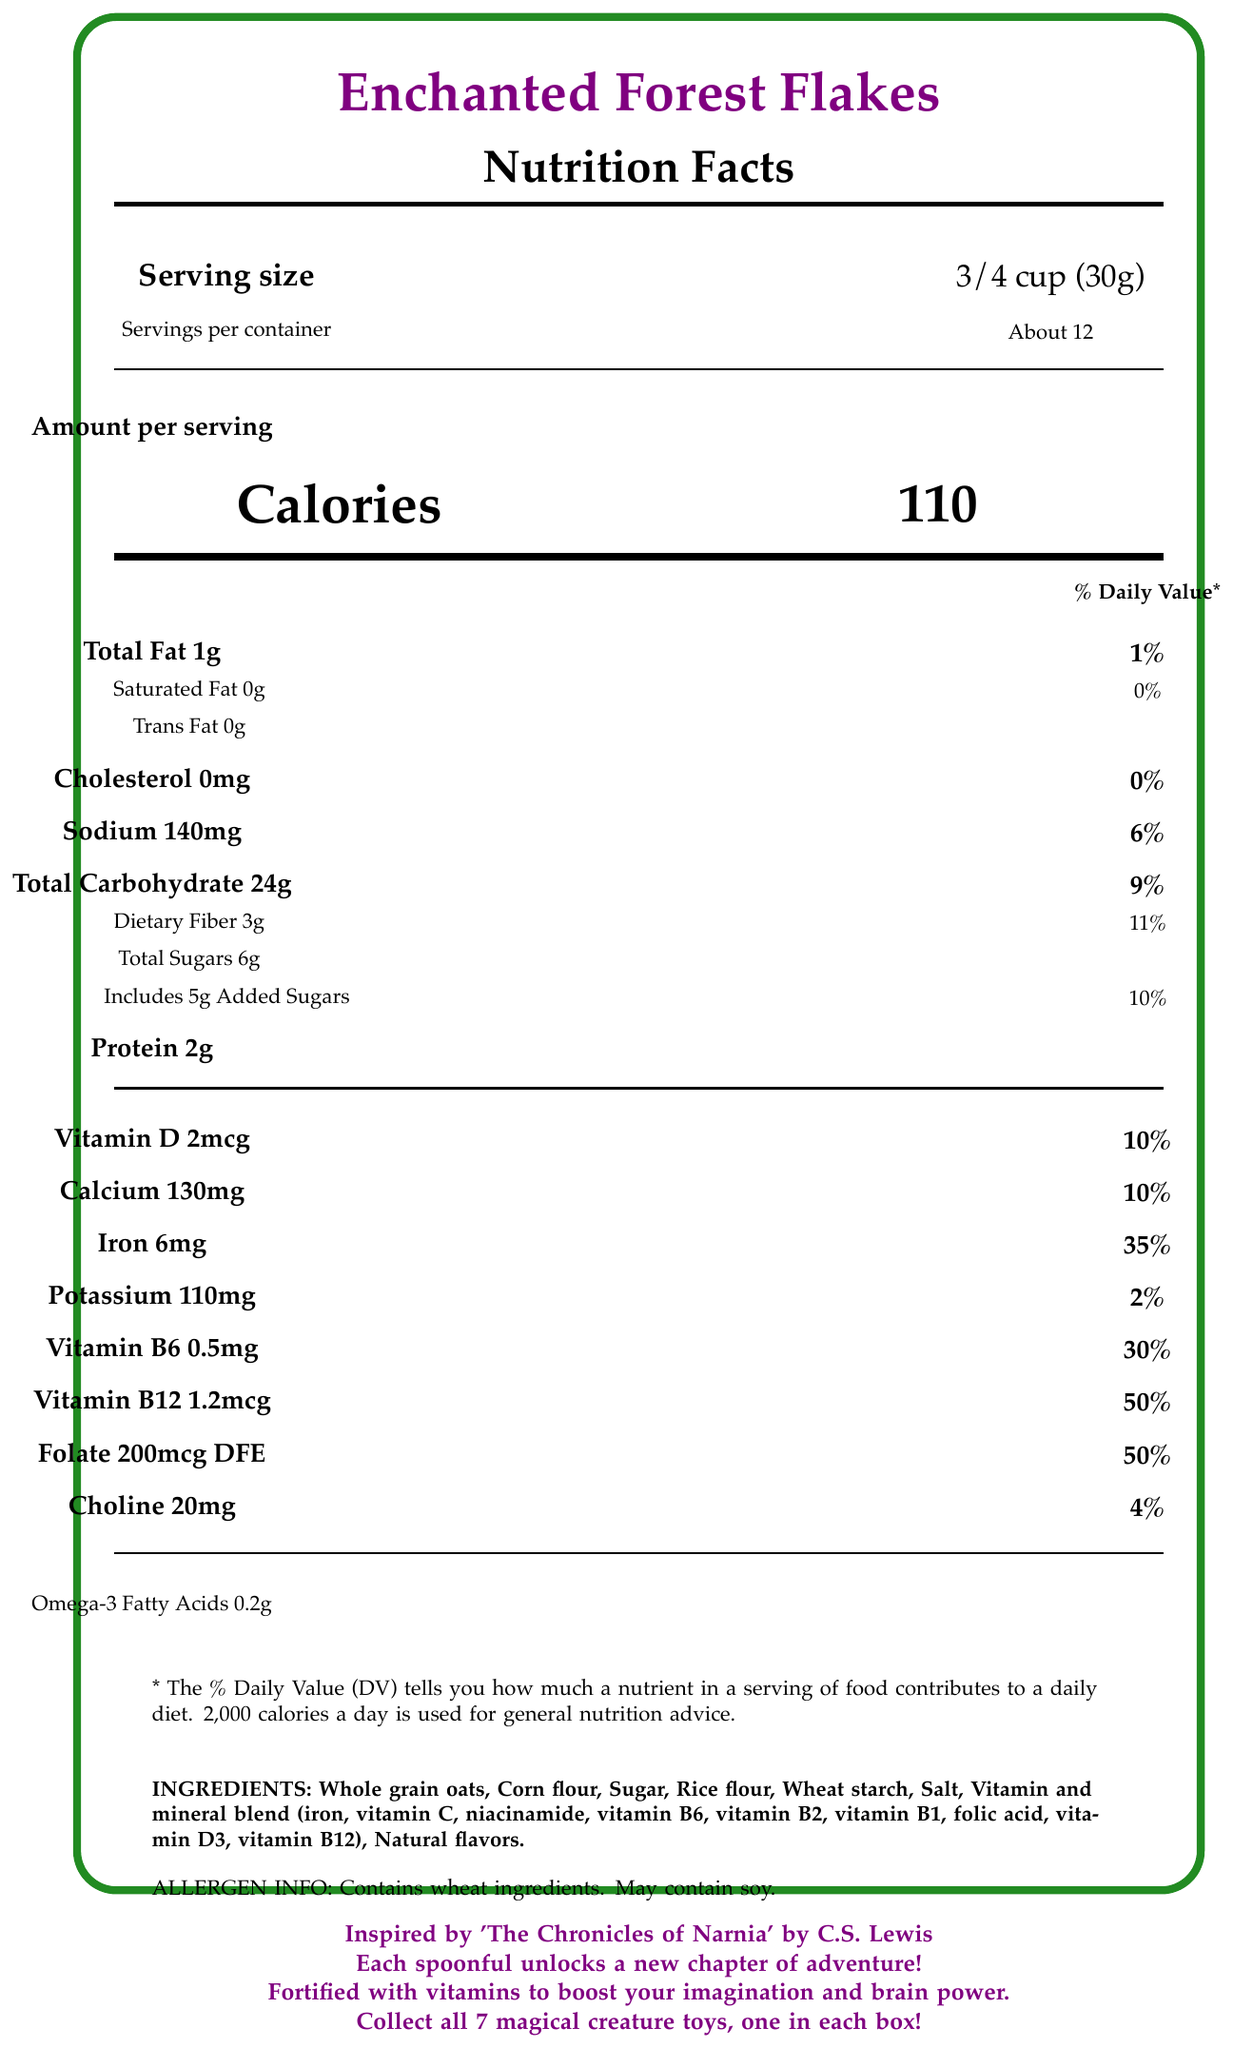what is the serving size? The serving size is clearly mentioned as 3/4 cup (30g) in the rendered document.
Answer: 3/4 cup (30g) how many calories are in one serving? The document specifies that the amount per serving is 110 calories.
Answer: 110 which vitamin has the highest percentage of the daily value? A. Vitamin D B. Calcium C. Iron D. Folate Folate has a daily value of 50%, which is the highest compared to the other listed options.
Answer: D does the cereal contain any trans fat? The document states that there are 0g of trans fat in the cereal.
Answer: No what is the total carbohydrate content per serving? The total carbohydrate content per serving is clearly listed as 24g.
Answer: 24g what are the main ingredients of 'Enchanted Forest Flakes'? These ingredients are listed in the ingredients section of the document.
Answer: Whole grain oats, Corn flour, Sugar, Rice flour, Wheat starch, Salt, Vitamin and mineral blend, Natural flavors is there any added sugar in the cereal? The document lists total sugars as 6g and specifies that 5g are added sugars.
Answer: Yes how many servings per container are there? The document specifies that there are about 12 servings per container.
Answer: About 12 what is the percentage daily value of vitamin B12 per serving? The daily value percentage for vitamin B12 is listed as 50%.
Answer: 50% does the cereal contain any allergens? The allergen information section of the document states that the product contains wheat ingredients and may contain soy.
Answer: Yes what book series is 'Enchanted Forest Flakes' inspired by? The document mentions that the cereal is inspired by 'The Chronicles of Narnia' by C.S. Lewis.
Answer: 'The Chronicles of Narnia' by C.S. Lewis how much dietary fiber does one serving contain? The document specifies that each serving contains 3g of dietary fiber.
Answer: 3g which ingredient is not listed in the vitamin and mineral blend? A. Vitamin C B. Vitamin B6 C. Vitamin E D. Vitamin D3 Vitamin E is not mentioned in the vitamin and mineral blend listed in the document.
Answer: C how many grams of protein are there per serving? The document lists the protein content as 2g per serving.
Answer: 2g is choline included in the nutritional information? The nutritional information section lists choline as one of the nutrients, with an amount of 20mg and a daily value of 4%.
Answer: Yes what is the sodium content per serving? The sodium content per serving is listed as 140mg in the document.
Answer: 140mg summarize the main idea of the document The document focuses on providing detailed nutritional facts and emphasizing the product's connection to a beloved children's book series. It highlights the health benefits and adventure-inspired marketing aspects of the cereal.
Answer: The document provides nutritional information for 'Enchanted Forest Flakes,' a children's adventure book series-themed breakfast cereal. It details serving size, calorie content, and the amounts of various nutrients, including several vitamins that support brain development. The cereal also ties in with 'The Chronicles of Narnia' by C.S. Lewis, offering children an imaginative breakfast experience. how much omega-3 fatty acid is present per serving? The document explicitly mentions that each serving contains 0.2g of omega-3 fatty acids.
Answer: 0.2g is there enough information to know how the cereal boosts brain power? While the document mentions that the cereal is fortified with vitamins to boost brain power, it does not provide detailed information on the mechanisms or specific effects of these vitamins on brain function.
Answer: Not enough information 